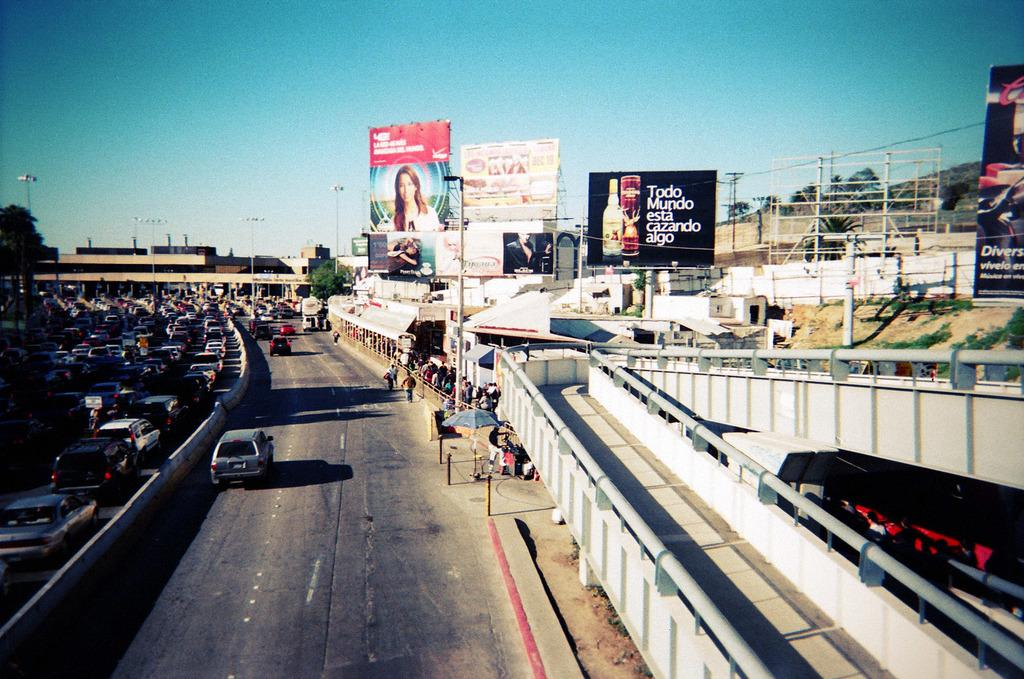What is the main feature of the image? There is a road in the image. Can you describe the people in the image? There are people in the image. What is the purpose of the railing in the image? The railing is likely for safety or to prevent people from falling. What is the umbrella used for in the image? The umbrella might be used for shade or protection from the sun or rain. What type of vegetation is present in the image? There are trees in the image. What are the hoardings in the image used for? The hoardings are likely used for advertising or displaying information. What are the light poles in the image used for? The light poles are likely used for providing light at night or during low visibility conditions. What type of vehicles are on the road in the image? There are vehicles on the road in the image, but their specific types are not mentioned. What structures can be seen in the image? There are buildings in the image. What part of the natural environment is visible in the image? The sky is visible in the image. What other objects are present in the image? There are objects in the image, but their specific types are not mentioned. Can you tell me how the guitar is balanced on the low branch of the tree in the image? There is no guitar or low branch of a tree present in the image. 